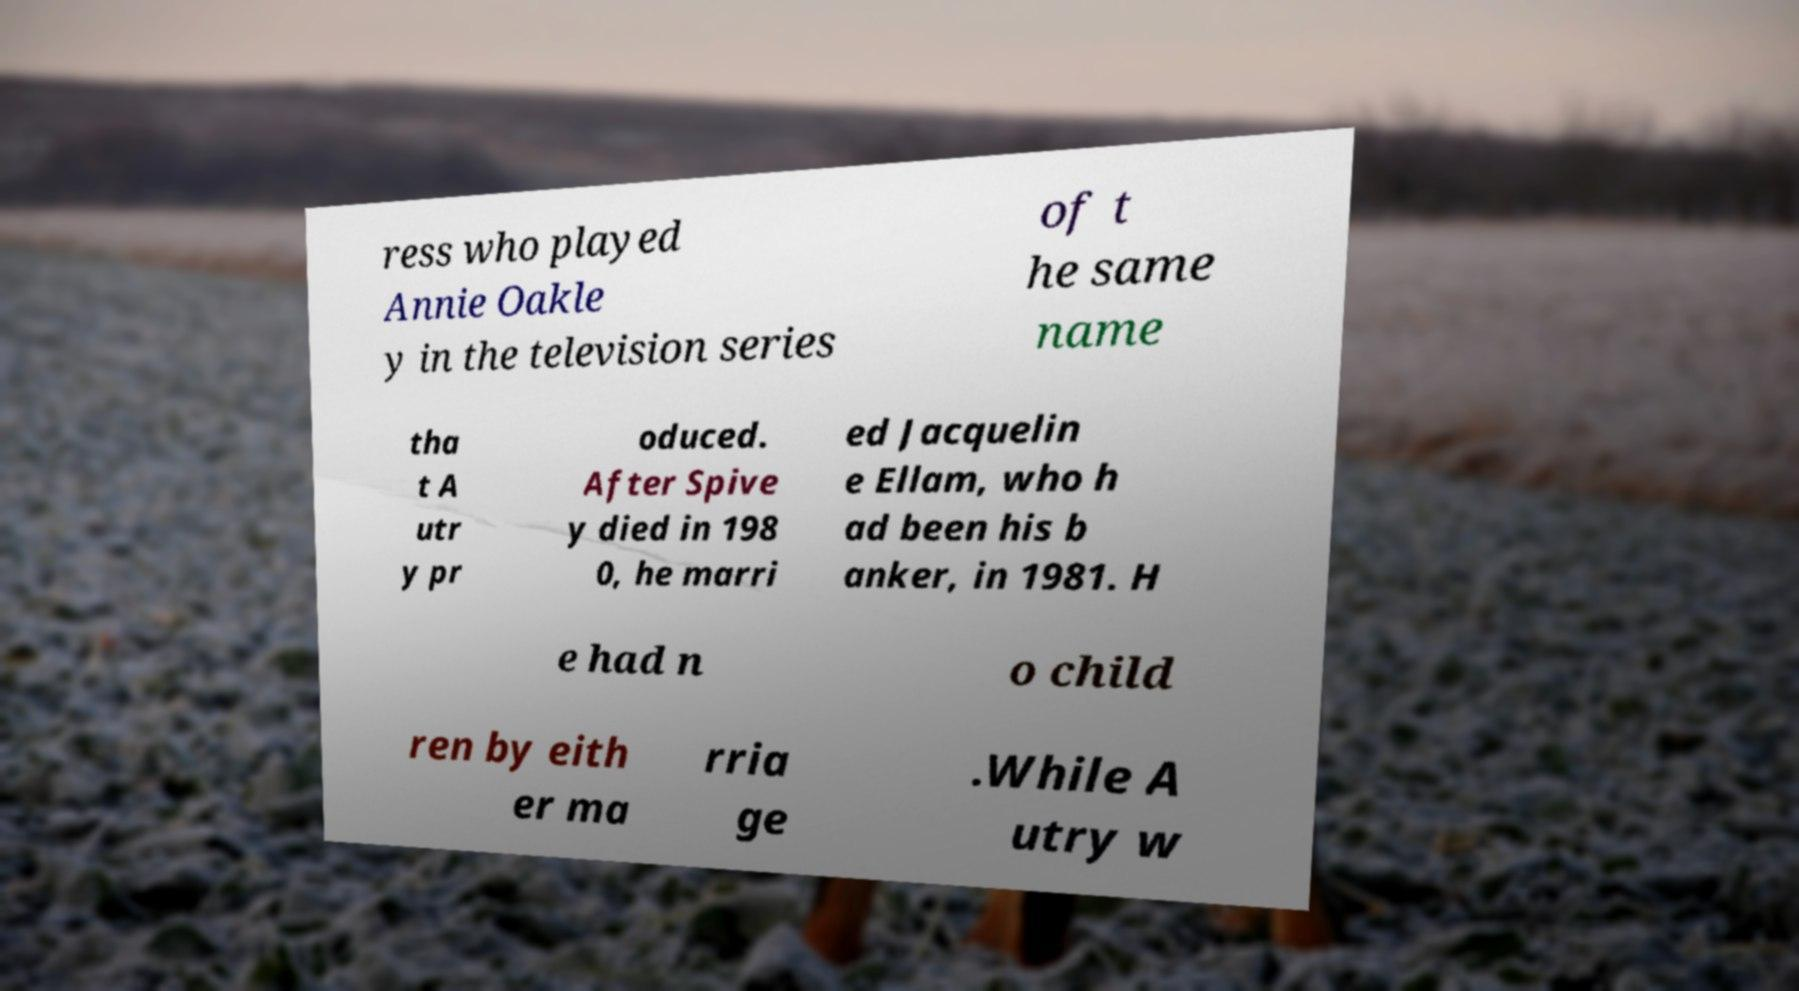I need the written content from this picture converted into text. Can you do that? ress who played Annie Oakle y in the television series of t he same name tha t A utr y pr oduced. After Spive y died in 198 0, he marri ed Jacquelin e Ellam, who h ad been his b anker, in 1981. H e had n o child ren by eith er ma rria ge .While A utry w 